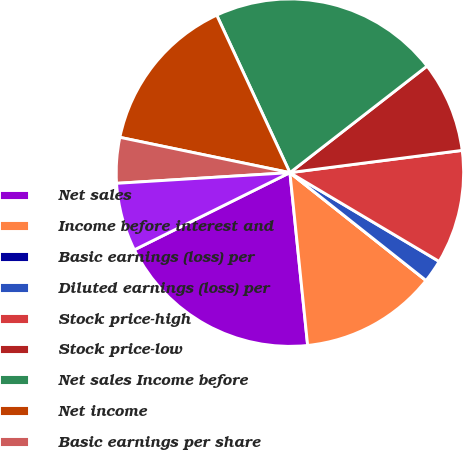Convert chart to OTSL. <chart><loc_0><loc_0><loc_500><loc_500><pie_chart><fcel>Net sales<fcel>Income before interest and<fcel>Basic earnings (loss) per<fcel>Diluted earnings (loss) per<fcel>Stock price-high<fcel>Stock price-low<fcel>Net sales Income before<fcel>Net income<fcel>Basic earnings per share<fcel>Diluted earnings per share<nl><fcel>19.3%<fcel>12.71%<fcel>0.0%<fcel>2.12%<fcel>10.59%<fcel>8.47%<fcel>21.41%<fcel>14.82%<fcel>4.24%<fcel>6.35%<nl></chart> 